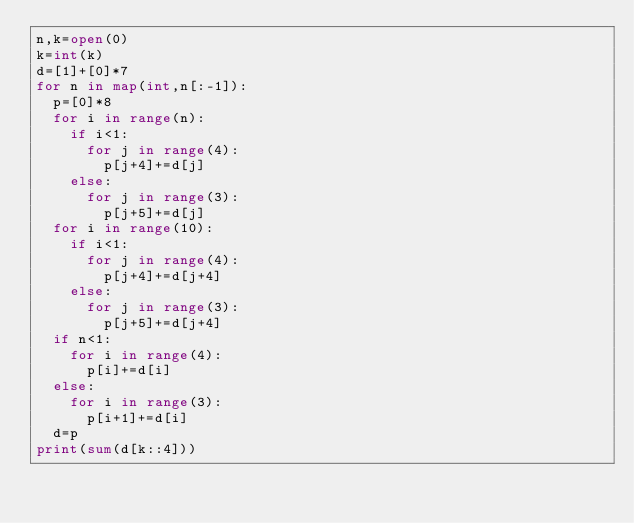Convert code to text. <code><loc_0><loc_0><loc_500><loc_500><_Python_>n,k=open(0)
k=int(k)
d=[1]+[0]*7
for n in map(int,n[:-1]):
  p=[0]*8
  for i in range(n):
    if i<1:
      for j in range(4):
        p[j+4]+=d[j]
    else:
      for j in range(3):
        p[j+5]+=d[j]
  for i in range(10):
    if i<1:
      for j in range(4):
        p[j+4]+=d[j+4]
    else:
      for j in range(3):
        p[j+5]+=d[j+4]
  if n<1:
    for i in range(4):
      p[i]+=d[i]
  else:
    for i in range(3):
      p[i+1]+=d[i]
  d=p
print(sum(d[k::4]))</code> 